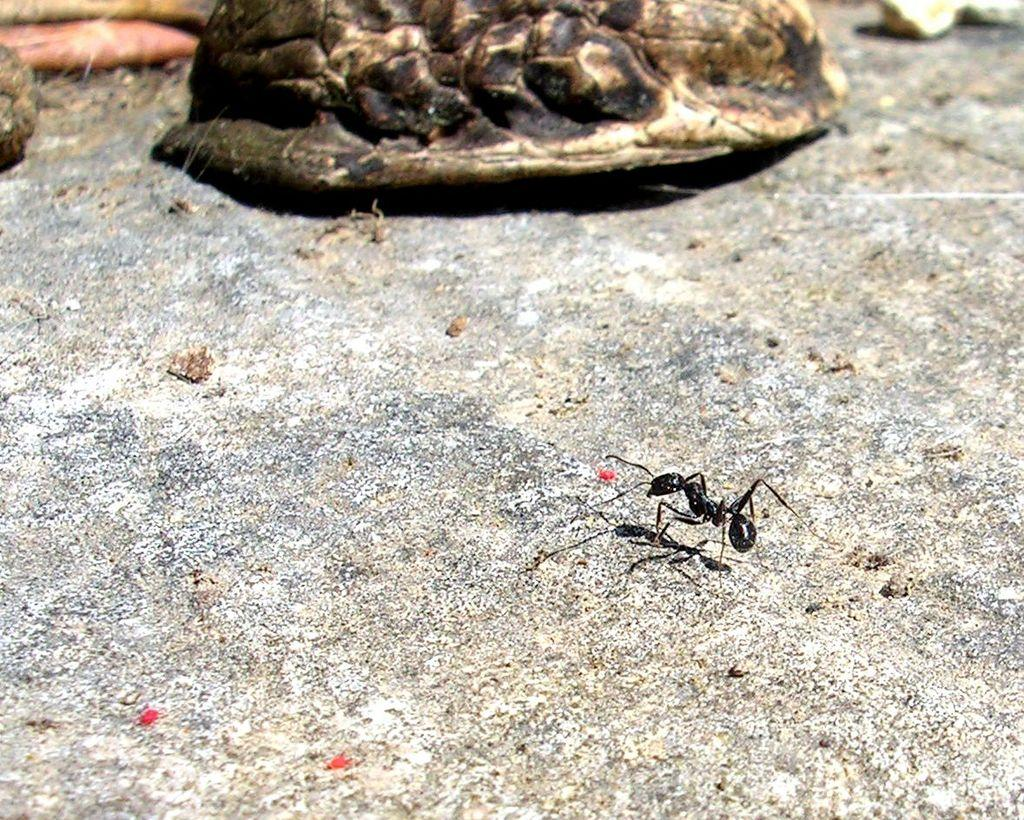What type of insect is present in the image? There is a black ant in the image. Where is the black ant located? The black ant is on the ground. What type of action is the black ant performing in the image? The image does not show the black ant performing any specific action. 